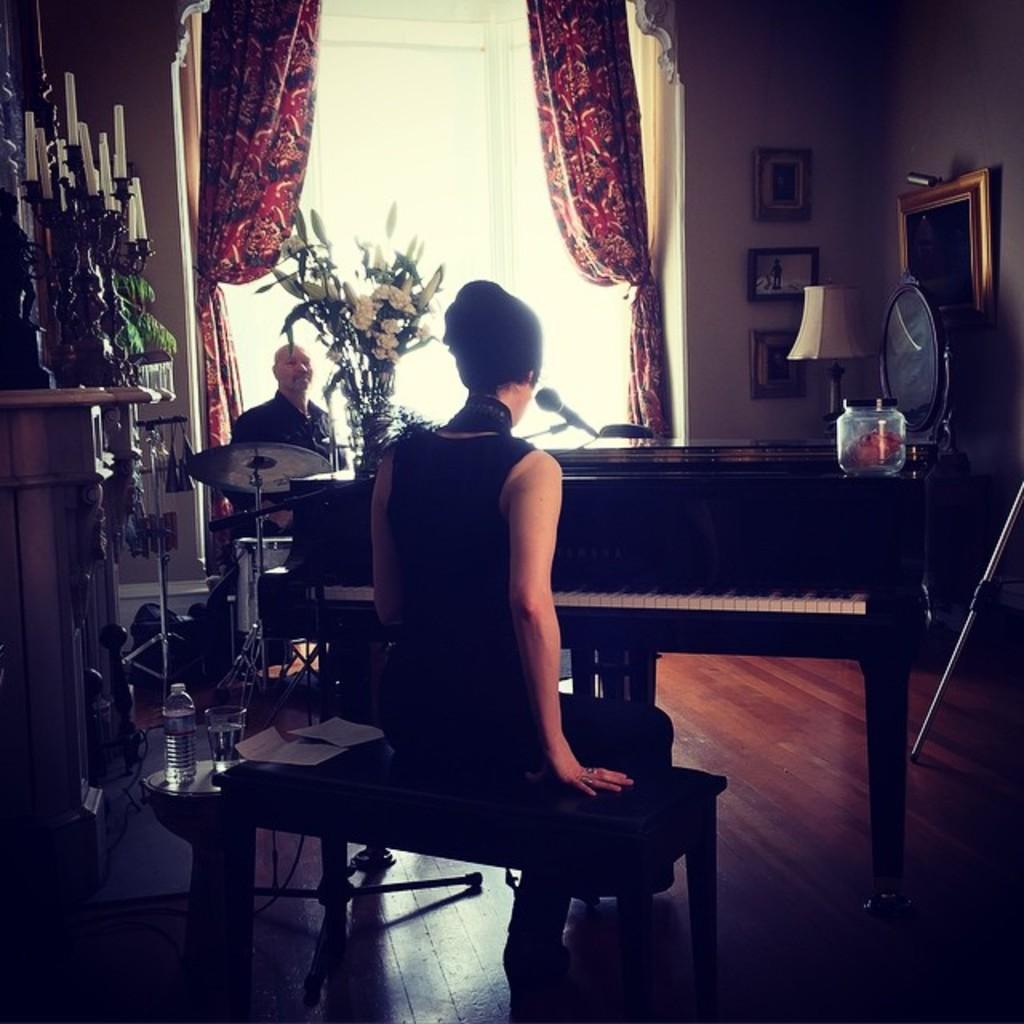In one or two sentences, can you explain what this image depicts? Here is the woman sitting on the stool. This is a piano. I can see a flower vase and a jar placed on the piano. Here is another man sitting. This is a water bottle and glass on a small table. These are the papers. This looks like a candles with a candles stand. These are the curtains hanging. This is a mirror. These are the frames attached to the wall. This is the lamp. 